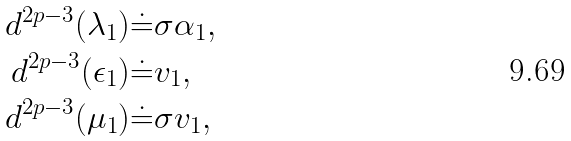Convert formula to latex. <formula><loc_0><loc_0><loc_500><loc_500>d ^ { 2 p - 3 } ( \lambda _ { 1 } ) \dot { = } & \sigma \alpha _ { 1 } , \\ d ^ { 2 p - 3 } ( \epsilon _ { 1 } ) \dot { = } & v _ { 1 } , \\ d ^ { 2 p - 3 } ( \mu _ { 1 } ) \dot { = } & \sigma v _ { 1 } ,</formula> 